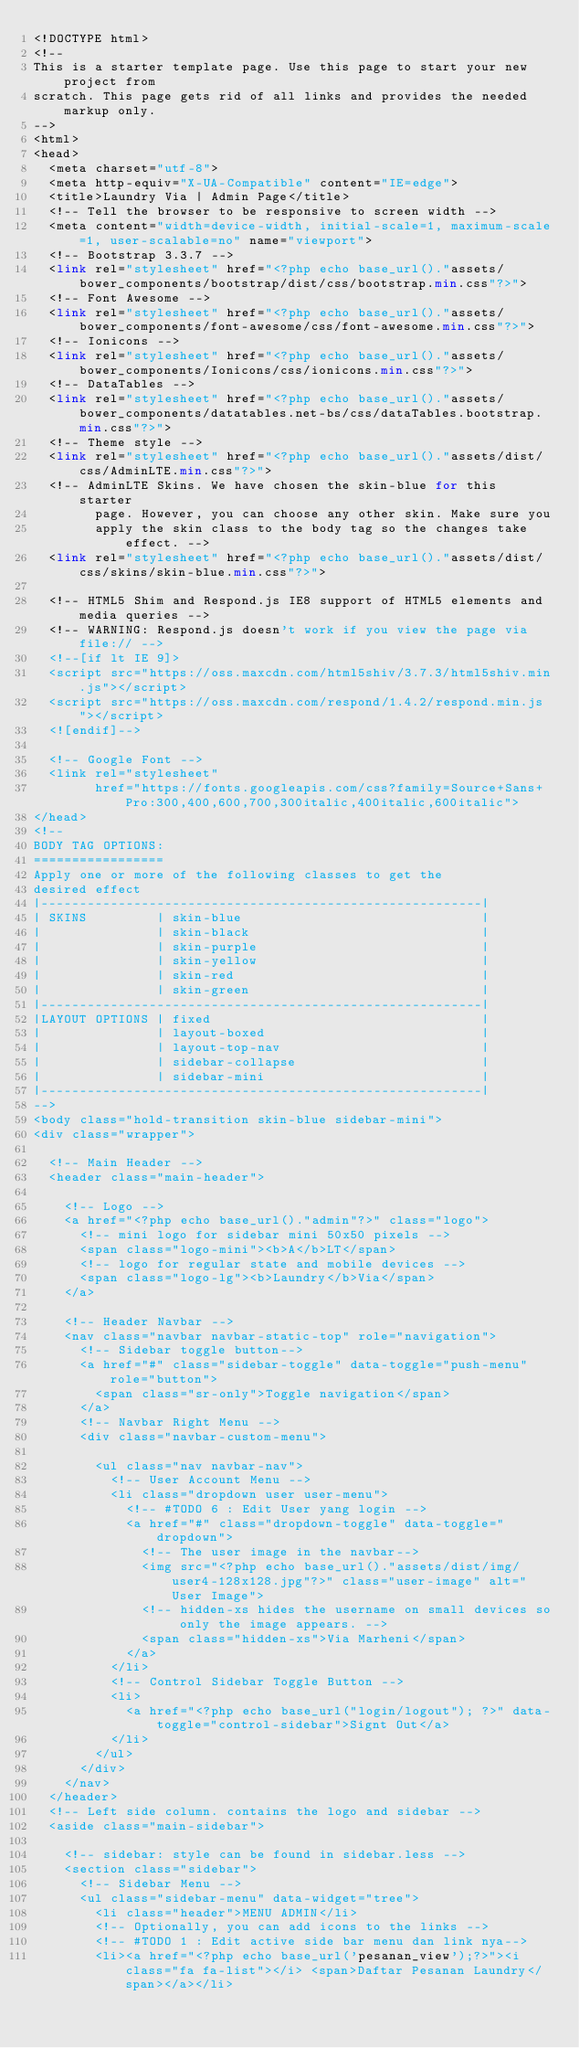<code> <loc_0><loc_0><loc_500><loc_500><_PHP_><!DOCTYPE html>
<!--
This is a starter template page. Use this page to start your new project from
scratch. This page gets rid of all links and provides the needed markup only.
-->
<html>
<head>
  <meta charset="utf-8">
  <meta http-equiv="X-UA-Compatible" content="IE=edge">
  <title>Laundry Via | Admin Page</title>
  <!-- Tell the browser to be responsive to screen width -->
  <meta content="width=device-width, initial-scale=1, maximum-scale=1, user-scalable=no" name="viewport">
  <!-- Bootstrap 3.3.7 -->
  <link rel="stylesheet" href="<?php echo base_url()."assets/bower_components/bootstrap/dist/css/bootstrap.min.css"?>">
  <!-- Font Awesome -->
  <link rel="stylesheet" href="<?php echo base_url()."assets/bower_components/font-awesome/css/font-awesome.min.css"?>">
  <!-- Ionicons -->
  <link rel="stylesheet" href="<?php echo base_url()."assets/bower_components/Ionicons/css/ionicons.min.css"?>">
  <!-- DataTables -->
  <link rel="stylesheet" href="<?php echo base_url()."assets/bower_components/datatables.net-bs/css/dataTables.bootstrap.min.css"?>">  
  <!-- Theme style -->
  <link rel="stylesheet" href="<?php echo base_url()."assets/dist/css/AdminLTE.min.css"?>">
  <!-- AdminLTE Skins. We have chosen the skin-blue for this starter
        page. However, you can choose any other skin. Make sure you
        apply the skin class to the body tag so the changes take effect. -->
  <link rel="stylesheet" href="<?php echo base_url()."assets/dist/css/skins/skin-blue.min.css"?>">

  <!-- HTML5 Shim and Respond.js IE8 support of HTML5 elements and media queries -->
  <!-- WARNING: Respond.js doesn't work if you view the page via file:// -->
  <!--[if lt IE 9]>
  <script src="https://oss.maxcdn.com/html5shiv/3.7.3/html5shiv.min.js"></script>
  <script src="https://oss.maxcdn.com/respond/1.4.2/respond.min.js"></script>
  <![endif]-->

  <!-- Google Font -->
  <link rel="stylesheet"
        href="https://fonts.googleapis.com/css?family=Source+Sans+Pro:300,400,600,700,300italic,400italic,600italic">
</head>
<!--
BODY TAG OPTIONS:
=================
Apply one or more of the following classes to get the
desired effect
|---------------------------------------------------------|
| SKINS         | skin-blue                               |
|               | skin-black                              |
|               | skin-purple                             |
|               | skin-yellow                             |
|               | skin-red                                |
|               | skin-green                              |
|---------------------------------------------------------|
|LAYOUT OPTIONS | fixed                                   |
|               | layout-boxed                            |
|               | layout-top-nav                          |
|               | sidebar-collapse                        |
|               | sidebar-mini                            |
|---------------------------------------------------------|
-->
<body class="hold-transition skin-blue sidebar-mini">
<div class="wrapper">

  <!-- Main Header -->
  <header class="main-header">

    <!-- Logo -->
    <a href="<?php echo base_url()."admin"?>" class="logo">
      <!-- mini logo for sidebar mini 50x50 pixels -->
      <span class="logo-mini"><b>A</b>LT</span>
      <!-- logo for regular state and mobile devices -->
      <span class="logo-lg"><b>Laundry</b>Via</span>
    </a>

    <!-- Header Navbar -->
    <nav class="navbar navbar-static-top" role="navigation">
      <!-- Sidebar toggle button-->
      <a href="#" class="sidebar-toggle" data-toggle="push-menu" role="button">
        <span class="sr-only">Toggle navigation</span>
      </a>
      <!-- Navbar Right Menu -->
      <div class="navbar-custom-menu">

        <ul class="nav navbar-nav">
          <!-- User Account Menu -->
          <li class="dropdown user user-menu">
            <!-- #TODO 6 : Edit User yang login -->
            <a href="#" class="dropdown-toggle" data-toggle="dropdown">
              <!-- The user image in the navbar-->
              <img src="<?php echo base_url()."assets/dist/img/user4-128x128.jpg"?>" class="user-image" alt="User Image">
              <!-- hidden-xs hides the username on small devices so only the image appears. -->
              <span class="hidden-xs">Via Marheni</span>
            </a>
          </li>
          <!-- Control Sidebar Toggle Button -->
          <li>
            <a href="<?php echo base_url("login/logout"); ?>" data-toggle="control-sidebar">Signt Out</a>
          </li>
        </ul>
      </div>
    </nav>
  </header>
  <!-- Left side column. contains the logo and sidebar -->
  <aside class="main-sidebar">

    <!-- sidebar: style can be found in sidebar.less -->
    <section class="sidebar">
      <!-- Sidebar Menu -->
      <ul class="sidebar-menu" data-widget="tree">
        <li class="header">MENU ADMIN</li>
        <!-- Optionally, you can add icons to the links -->
        <!-- #TODO 1 : Edit active side bar menu dan link nya-->
        <li><a href="<?php echo base_url('pesanan_view');?>"><i class="fa fa-list"></i> <span>Daftar Pesanan Laundry</span></a></li></code> 